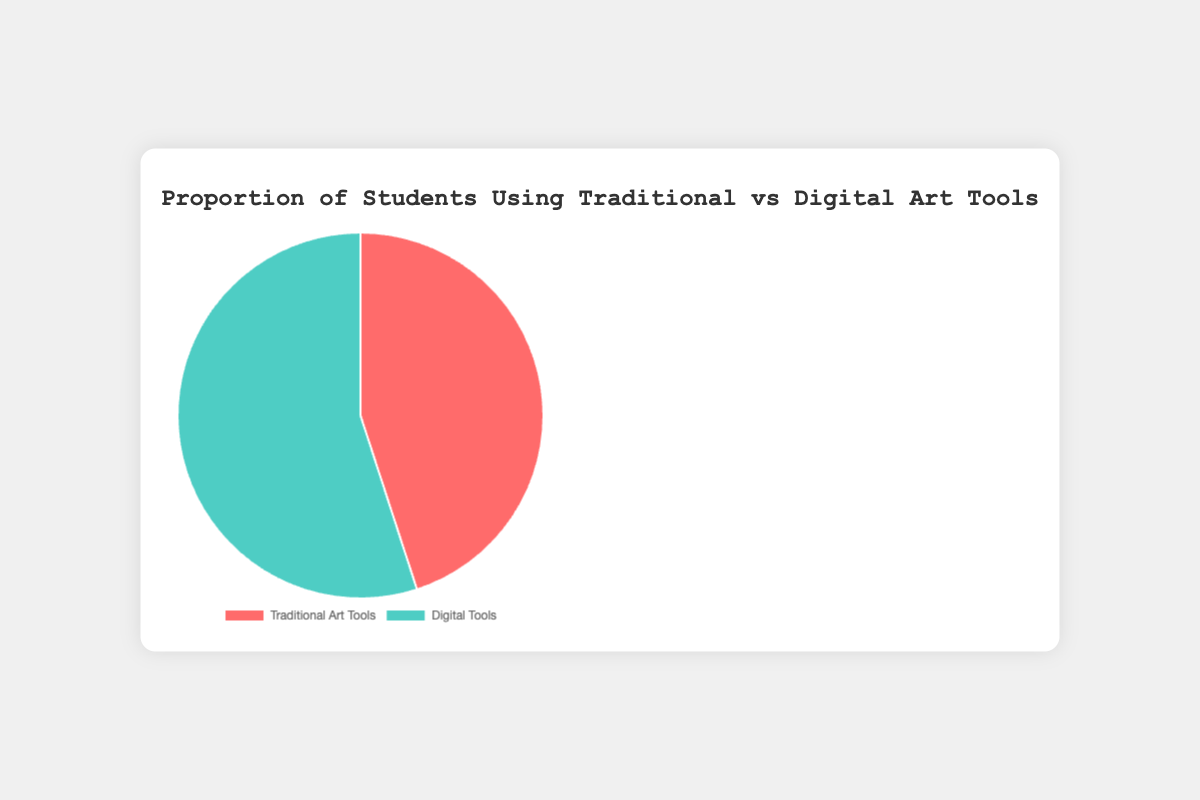what tools do students prefer more, traditional or digital? the pie chart shows two segments, one for traditional art tools and one for digital tools. The percentage for digital tools is higher at 55%, compared to 45% for traditional art tools. So, students prefer digital tools more.
Answer: digital tools By how much do digital tools surpass traditional tools in usage among students? the pie chart has different percentages for the two types of tools. Digital tools have 55% usage, while traditional tools have 45% usage. Subtracting the two gives 55% - 45% = 10%. So, digital tools surpass traditional tools by 10%.
Answer: 10% What fraction of students use traditional art tools? the pie chart shows that 45% of students use traditional art tools. So, to convert this to a fraction, 45% is equivalent to 45/100, which simplifies to 9/20.
Answer: 9/20 What is the ratio of students using digital tools to those using traditional tools? according to the pie chart, 55% of students use digital tools and 45% use traditional tools. The ratio is thus 55:45, which can be simplified by dividing both numbers by 5, resulting in a ratio of 11:9.
Answer: 11:9 If the total number of students is 200, how many students use traditional art tools? the pie chart shows that 45% of students use traditional art tools. We calculate the number of students by multiplying 45% by 200. This gives (45/100) * 200 = 90 students.
Answer: 90 What proportion of the pie chart's area is dedicated to students using digital tools? the pie chart visually represents proportions as segments of a circle. 55% of the circle’s area is dedicated to students using digital tools.
Answer: 55% Which color represents the segment for digital tools? the pie chart uses specific colors for each segment. The segment representing digital tools is shown in green.
Answer: green If the total number of students increased to 400, how many more students would be using digital tools? initially, with 200 students, 55% use digital tools, which is 110 students. If the total reaches 400, then 55% of 400 is (55/100) * 400 = 220 students. The increase in students using digital tools is 220 - 110 = 110.
Answer: 110 What percentage of students would use digital tools if 10% of the traditional tool users switched to digital tools? currently, 45% use traditional tools and 55% use digital tools. If 10% of traditional users switch to digital, that’s 10% of 45%, which is 4.5%. Adding this to the existing 55%, we get 55% + 4.5% = 59.5%. So, 59.5% of students would use digital tools.
Answer: 59.5% 